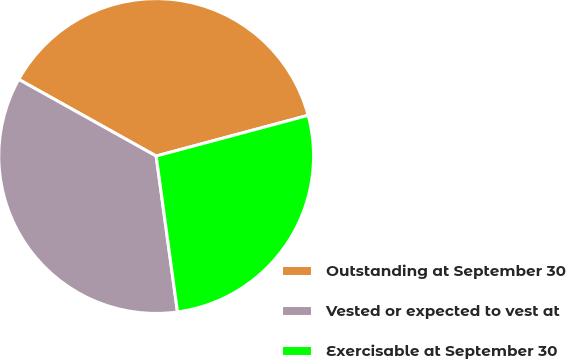<chart> <loc_0><loc_0><loc_500><loc_500><pie_chart><fcel>Outstanding at September 30<fcel>Vested or expected to vest at<fcel>Exercisable at September 30<nl><fcel>37.74%<fcel>35.26%<fcel>27.0%<nl></chart> 